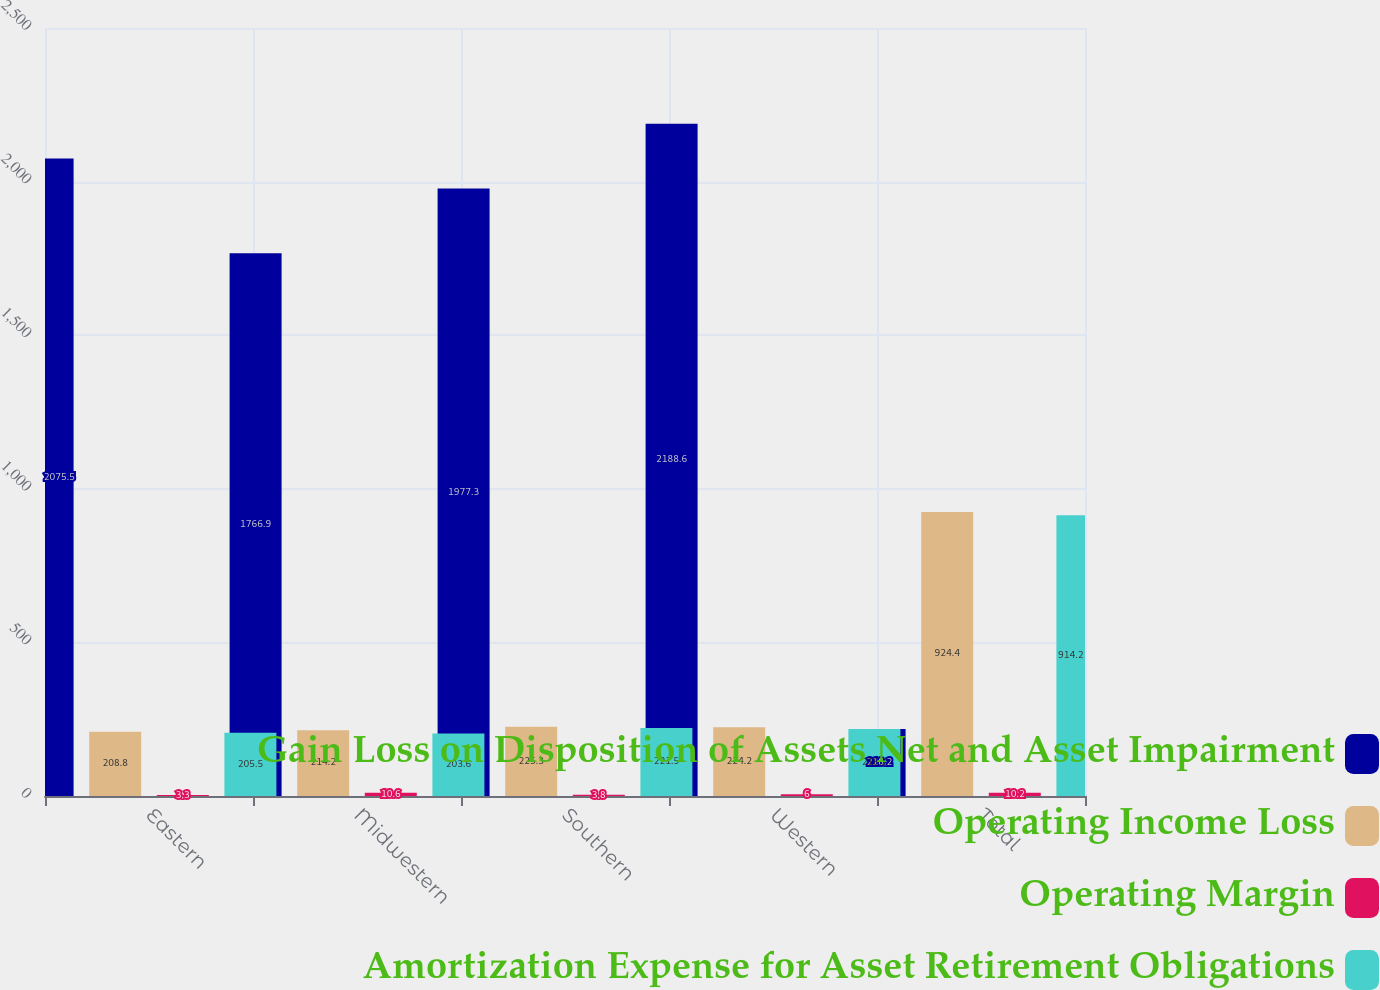<chart> <loc_0><loc_0><loc_500><loc_500><stacked_bar_chart><ecel><fcel>Eastern<fcel>Midwestern<fcel>Southern<fcel>Western<fcel>Total<nl><fcel>Gain Loss on Disposition of Assets Net and Asset Impairment<fcel>2075.5<fcel>1766.9<fcel>1977.3<fcel>2188.6<fcel>218.2<nl><fcel>Operating Income Loss<fcel>208.8<fcel>214.2<fcel>225.3<fcel>224.2<fcel>924.4<nl><fcel>Operating Margin<fcel>3.3<fcel>10.6<fcel>3.8<fcel>6<fcel>10.2<nl><fcel>Amortization Expense for Asset Retirement Obligations<fcel>205.5<fcel>203.6<fcel>221.5<fcel>218.2<fcel>914.2<nl></chart> 